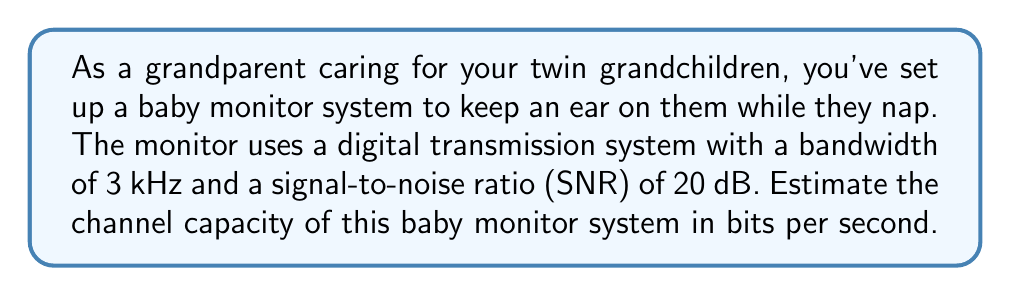Show me your answer to this math problem. To estimate the channel capacity of the baby monitor system, we'll use Shannon's channel capacity theorem. The steps are as follows:

1. Recall Shannon's channel capacity formula:
   $$C = B \log_2(1 + SNR)$$
   Where:
   $C$ is the channel capacity in bits per second
   $B$ is the bandwidth in Hz
   $SNR$ is the signal-to-noise ratio

2. We're given:
   Bandwidth ($B$) = 3 kHz = 3000 Hz
   SNR = 20 dB

3. Convert SNR from dB to a linear scale:
   $$SNR_{linear} = 10^{SNR_{dB}/10} = 10^{20/10} = 100$$

4. Plug the values into Shannon's formula:
   $$C = 3000 \log_2(1 + 100)$$

5. Simplify:
   $$C = 3000 \log_2(101)$$

6. Calculate:
   $$C \approx 3000 \times 6.658 \approx 19,974 \text{ bits per second}$$

7. Round to a sensible number of significant figures:
   $$C \approx 20,000 \text{ bits per second}$$
Answer: The estimated channel capacity of the baby monitor system is approximately 20,000 bits per second. 